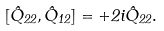<formula> <loc_0><loc_0><loc_500><loc_500>[ \hat { Q } _ { 2 2 } , \hat { Q } _ { 1 2 } ] = + 2 i \hat { Q } _ { 2 2 } .</formula> 